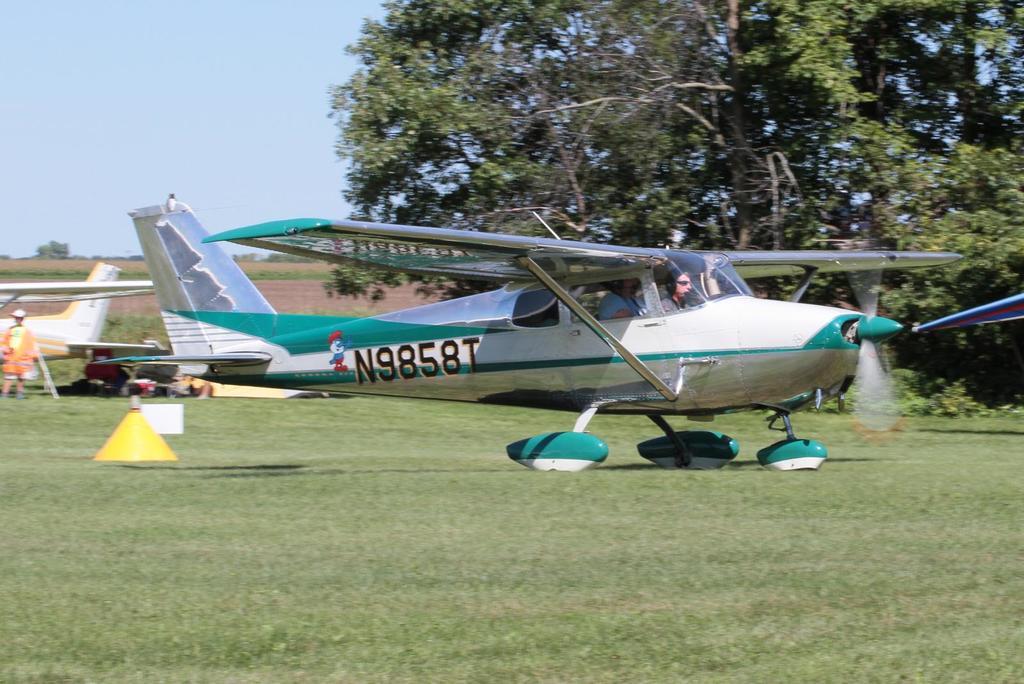What is the name of this plane?
Offer a very short reply. N9858t. What is the identifying letter/number combination on the side of the plane?
Your response must be concise. N9858t. 